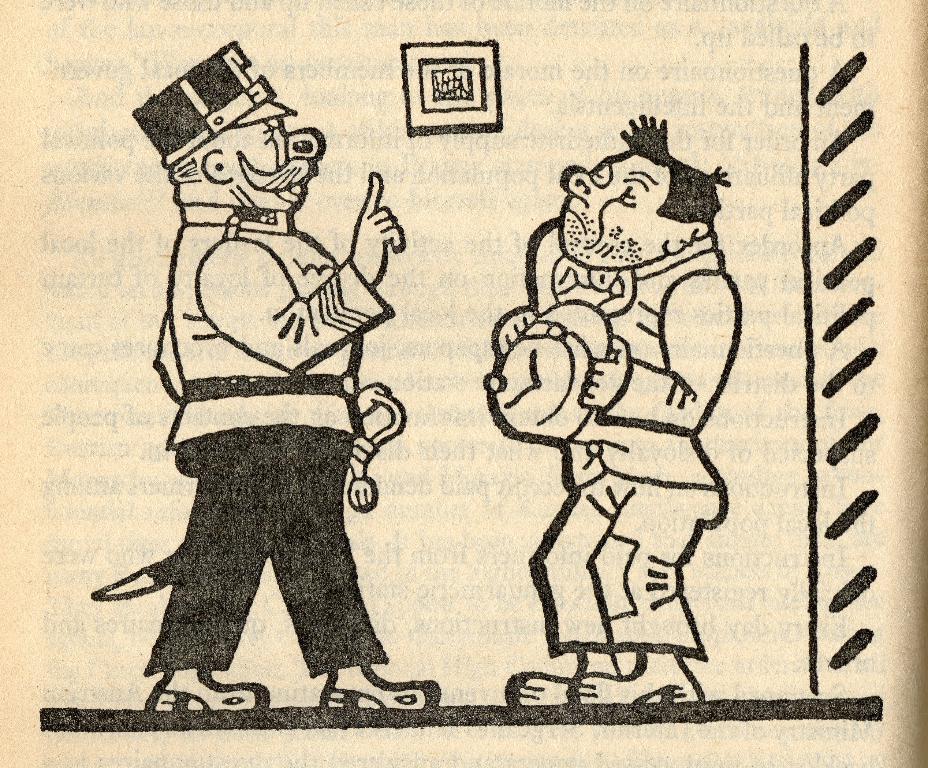Could you give a brief overview of what you see in this image? In this image I can see white colour page and on it I can see few cartoons. I can see colour of these cartoons are white and black. 